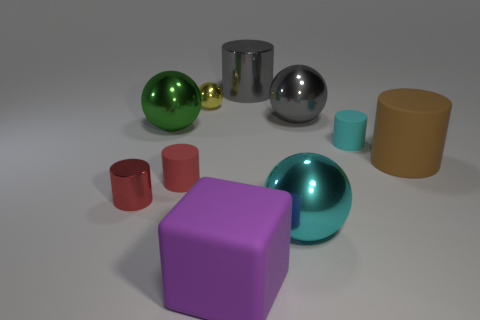Subtract all brown cylinders. How many cylinders are left? 4 Subtract all cyan rubber cylinders. How many cylinders are left? 4 Subtract all blue cylinders. Subtract all gray blocks. How many cylinders are left? 5 Subtract all cubes. How many objects are left? 9 Subtract all metal things. Subtract all big matte things. How many objects are left? 2 Add 8 brown rubber cylinders. How many brown rubber cylinders are left? 9 Add 4 large gray metal cubes. How many large gray metal cubes exist? 4 Subtract 0 gray cubes. How many objects are left? 10 